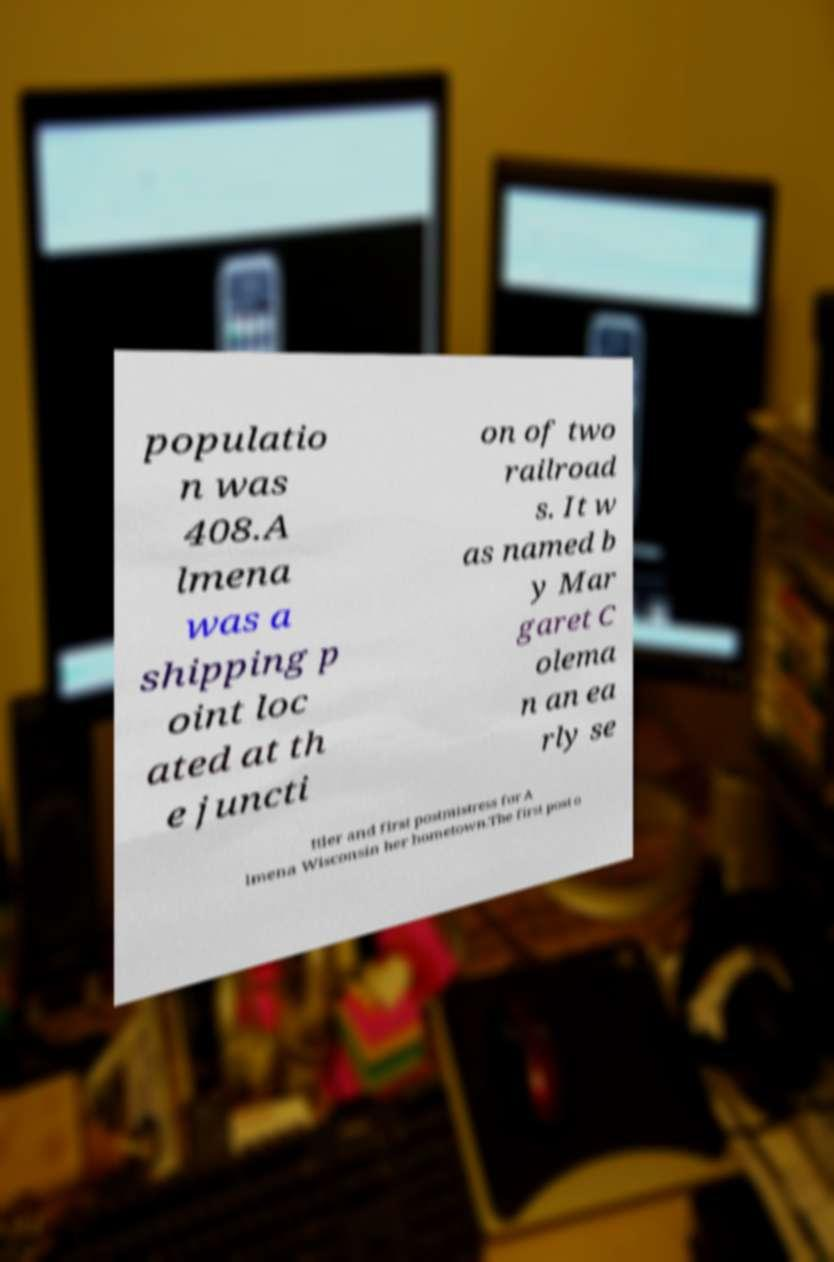I need the written content from this picture converted into text. Can you do that? populatio n was 408.A lmena was a shipping p oint loc ated at th e juncti on of two railroad s. It w as named b y Mar garet C olema n an ea rly se ttler and first postmistress for A lmena Wisconsin her hometown.The first post o 